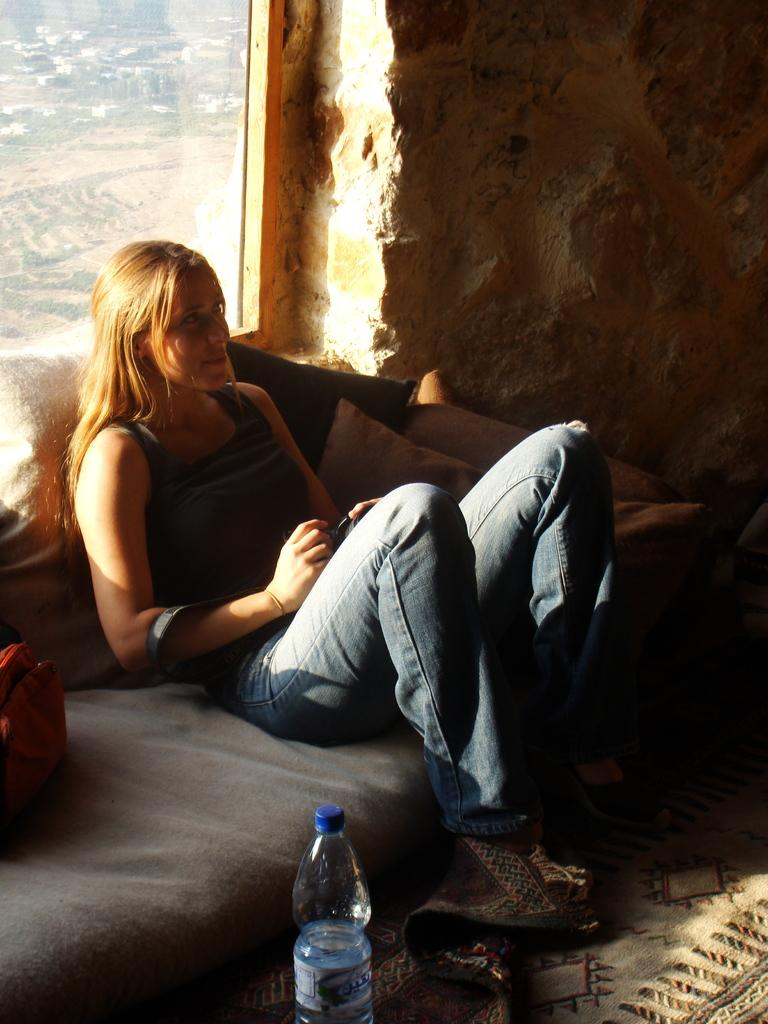Who is present in the image? There is a woman in the image. What type of clothing is the woman wearing? The woman is wearing jeans. What is the woman doing in the image? The woman is sitting on a couch. What can be seen near the woman? There is a water bottle in the image. What is visible in the background of the image? There is a window with a view of the city, and there is a wall in the background. What type of toy is the woman playing with in the image? There is no toy present in the image; the woman is sitting on a couch and there is a water bottle nearby. 